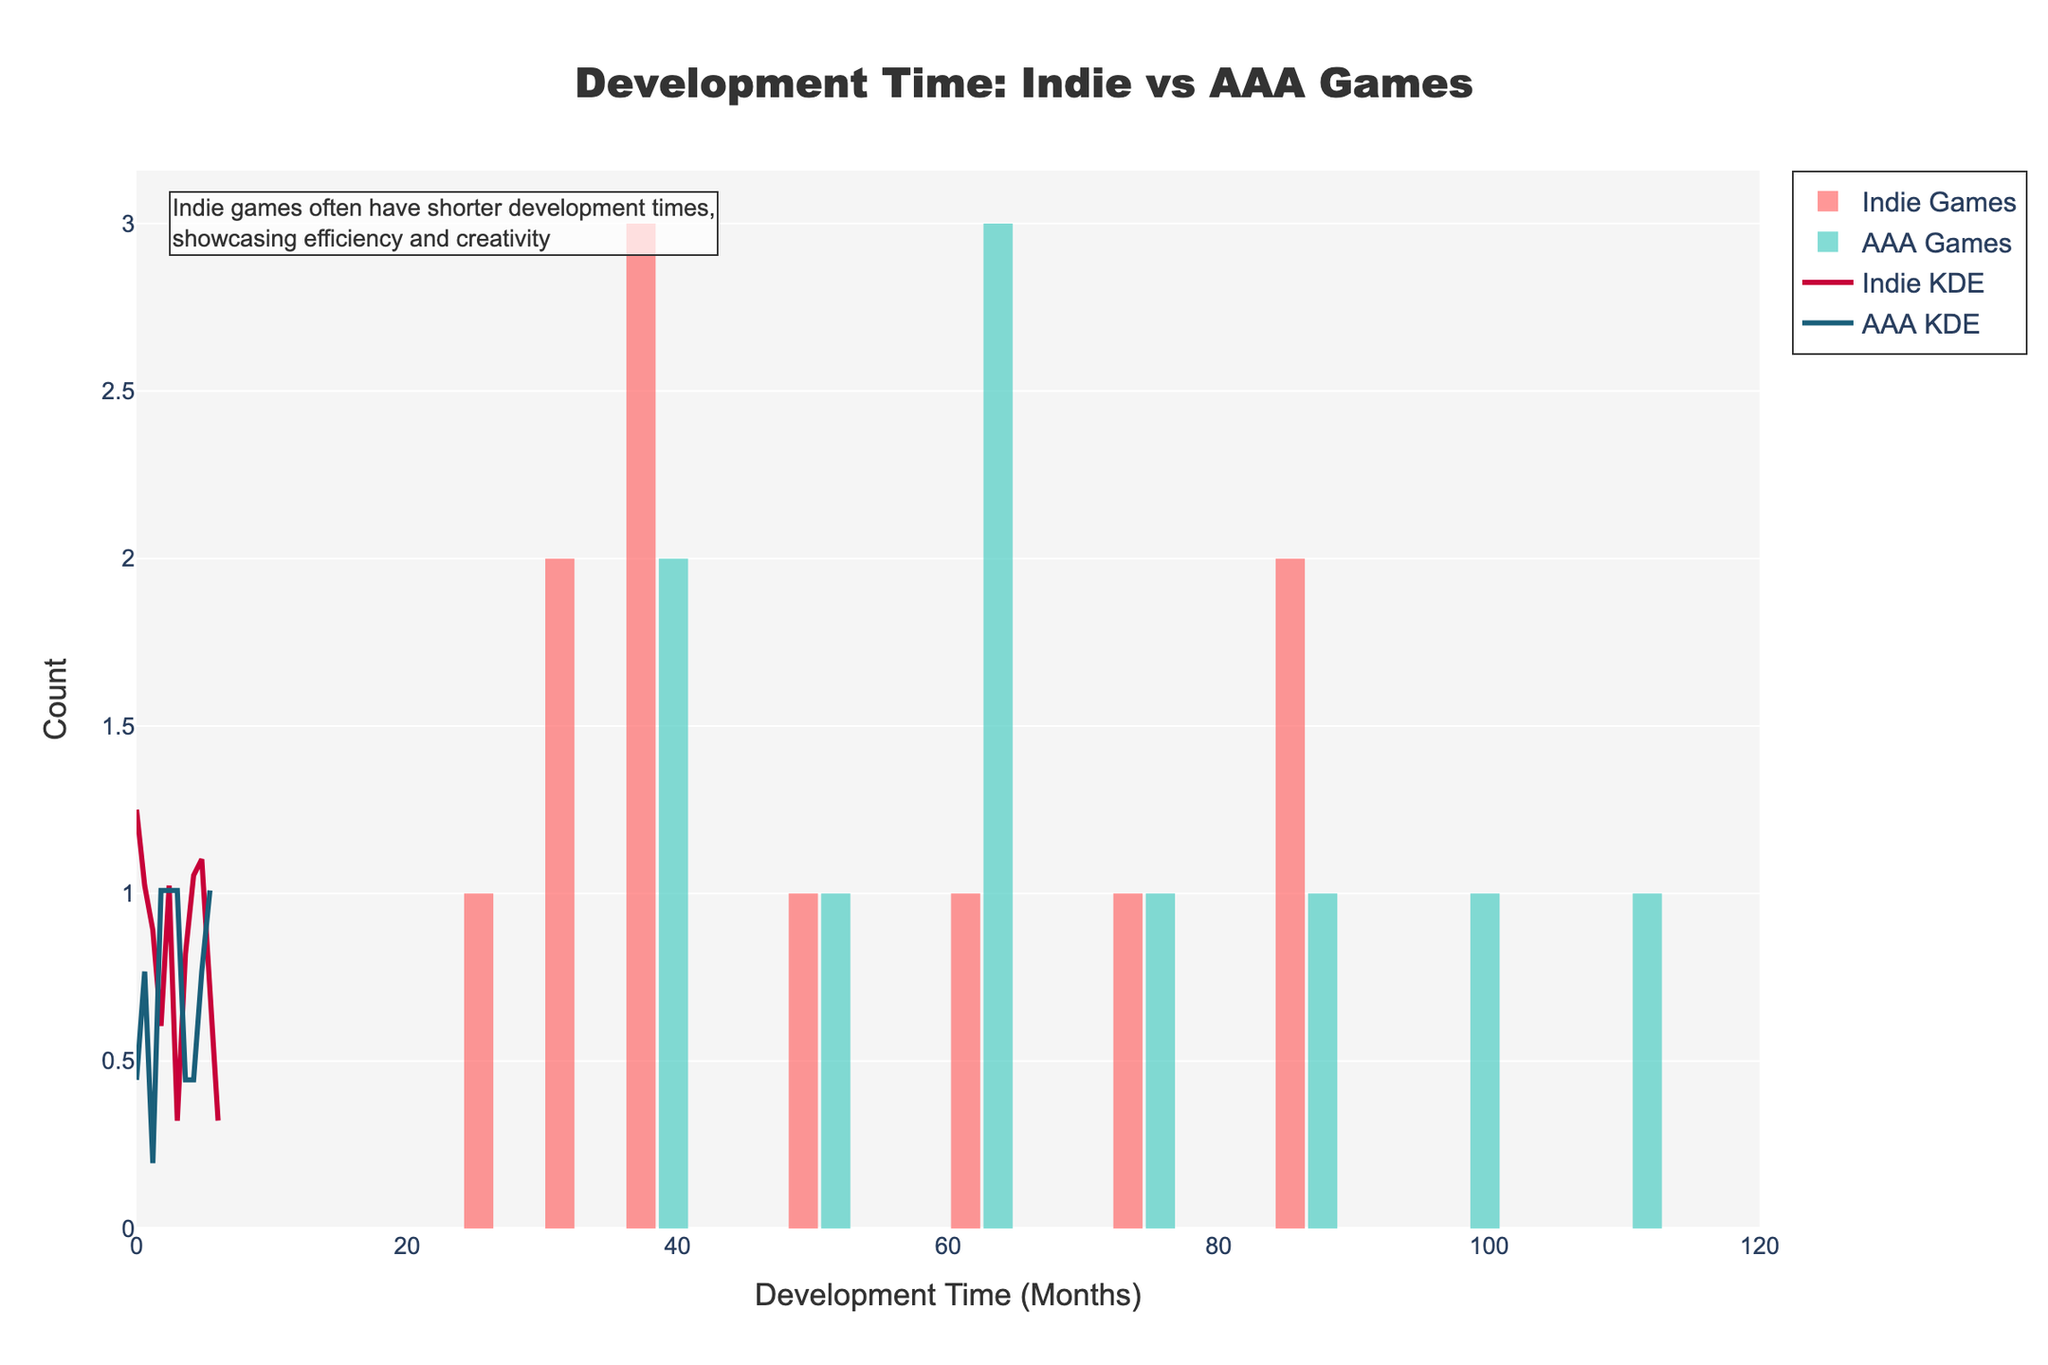What is the title of the figure? The title is centered at the top of the figure and clearly visible in a larger font.
Answer: Development Time: Indie vs AAA Games What type of games seem to have a wider range of development times? By observing the histograms and KDE curves, one can note that the histograms for AAA games show a wider spread of development times, indicating a broader range.
Answer: AAA Games Which type of games appears to have the longer average development time? The peak of the KDE curve for AAA games is positioned further to the right compared to the Indie games, suggesting that AAA games generally have longer development times.
Answer: AAA Games How many data points are there for Indie games? By looking at the individual bars and counting them, we can see that there are 11 bars representing Indie games.
Answer: 11 At what development time (in months) do the Indie games show the highest density in the KDE curve? The KDE curve for Indie games peaks around 36 months, indicating the highest density of development times.
Answer: 36 months What's the development time for the shortest AAA title and the longest Indie game? By observing the x-axis for the shortest series of bars for AAA games and the longest series for Indie games: the shortest AAA title has a development time of 36 months, and the longest Indie game has a development time of 84 months.
Answer: 36 months for AAA, 84 months for Indie Which game type shows a more concentrated development time range? Looking at the spread and peaks of the histograms and KDE curves, Indie games display a more concentrated development time range, mostly clustering around 30-60 months.
Answer: Indie Games How does the development time distribution compare between Indie and AAA games in the KDE plots? The KDE plot for Indie games is more concentrated with a distinctive peak, whereas the KDE plot for AAA games is broader with multiple significant peaks, indicating more variability in development times.
Answer: Indie games are more concentrated; AAA games are more variable What can be inferred about the frequency of games taking 60 months to develop? By observing the histogram bars at 60 months for both Indie and AAA games, it is evident that there are a few games (represented by taller bars) for both types showing that 60 months is a common development time.
Answer: 60 months is a common development time Which type of games shows more variability in their development times? The wider spread and multiple peaks in the AAA games histogram and KDE curve indicates greater variability in development times.
Answer: AAA Games 